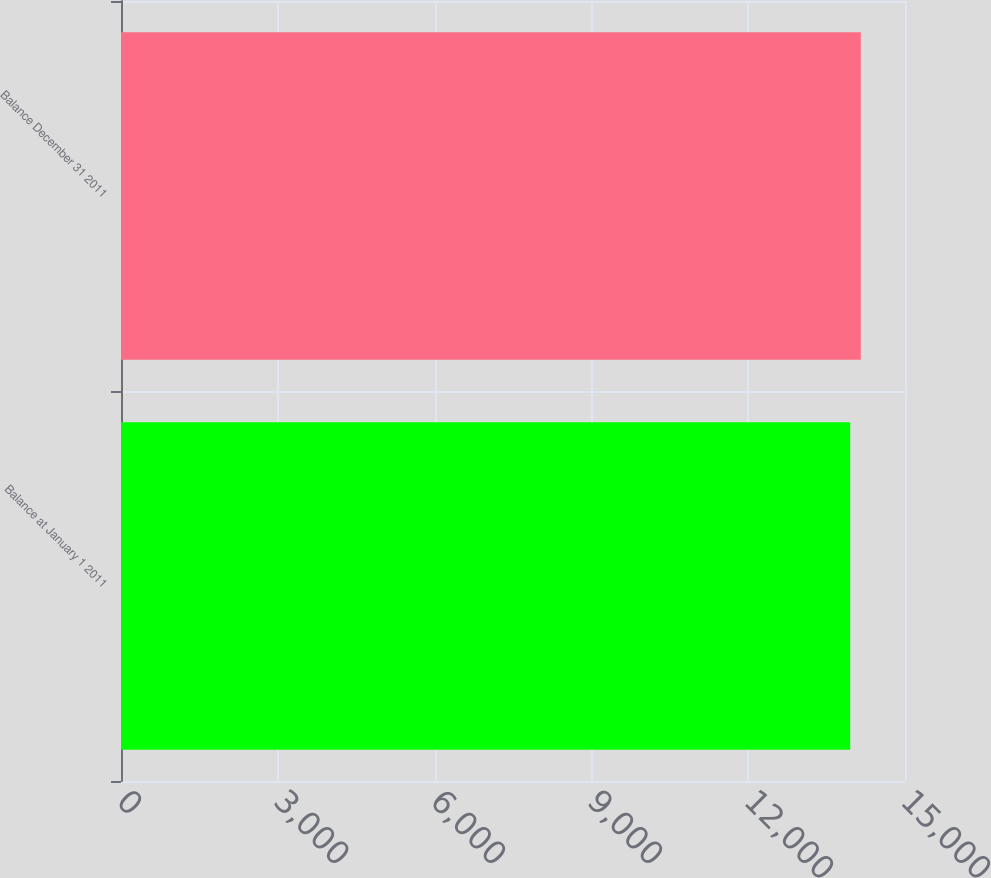<chart> <loc_0><loc_0><loc_500><loc_500><bar_chart><fcel>Balance at January 1 2011<fcel>Balance December 31 2011<nl><fcel>13952<fcel>14154<nl></chart> 